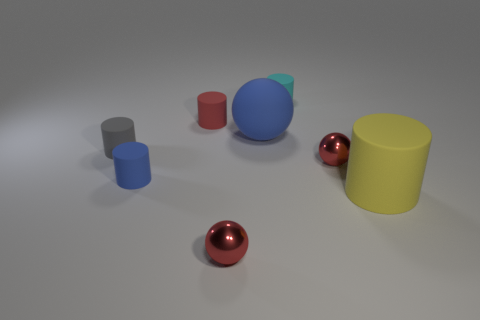Is there a matte cylinder that has the same color as the matte sphere?
Keep it short and to the point. Yes. What size is the rubber object that is the same color as the matte sphere?
Give a very brief answer. Small. There is a small matte cylinder that is in front of the gray rubber cylinder; is its color the same as the big rubber ball?
Your response must be concise. Yes. What material is the small object that is the same color as the large sphere?
Your answer should be compact. Rubber. Is the material of the cyan cylinder the same as the yellow cylinder that is in front of the big blue ball?
Your answer should be very brief. Yes. There is a sphere that is the same size as the yellow cylinder; what material is it?
Your answer should be compact. Rubber. Are there any red metallic things that have the same size as the yellow rubber object?
Your answer should be compact. No. The red rubber thing that is the same size as the blue cylinder is what shape?
Keep it short and to the point. Cylinder. How many other things are the same color as the matte ball?
Keep it short and to the point. 1. What is the shape of the small red thing that is both in front of the gray cylinder and on the left side of the cyan thing?
Ensure brevity in your answer.  Sphere. 